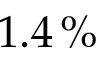Convert formula to latex. <formula><loc_0><loc_0><loc_500><loc_500>1 . 4 \, \%</formula> 